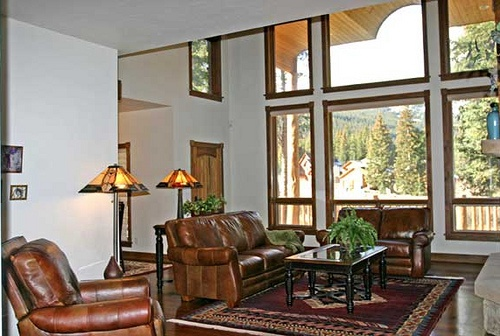Describe the objects in this image and their specific colors. I can see chair in black, brown, and maroon tones, couch in black, maroon, and gray tones, couch in black, maroon, and gray tones, potted plant in black and darkgreen tones, and couch in black and gray tones in this image. 